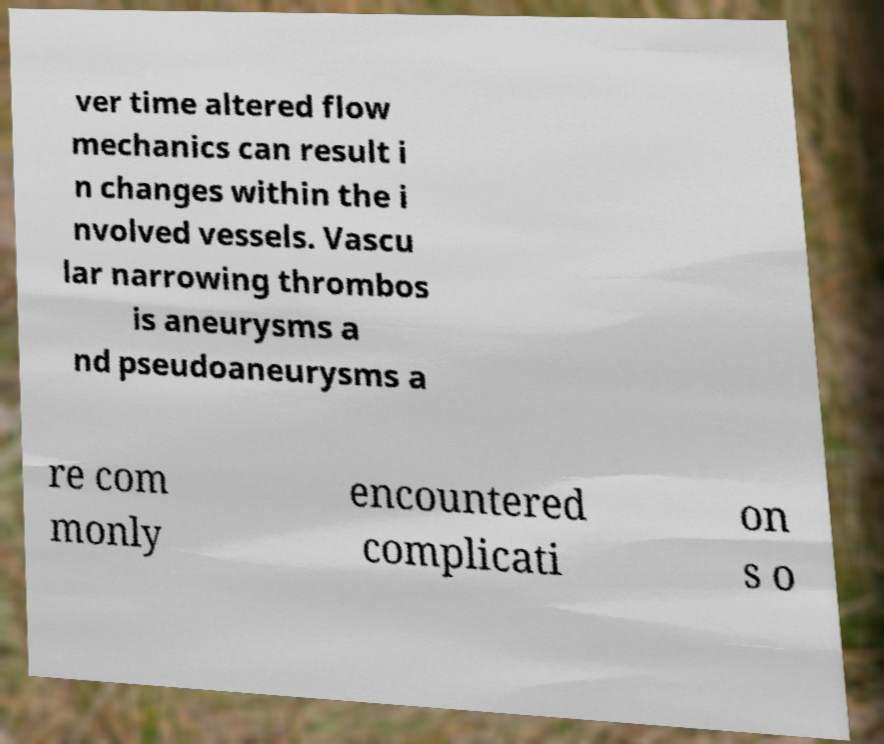I need the written content from this picture converted into text. Can you do that? ver time altered flow mechanics can result i n changes within the i nvolved vessels. Vascu lar narrowing thrombos is aneurysms a nd pseudoaneurysms a re com monly encountered complicati on s o 